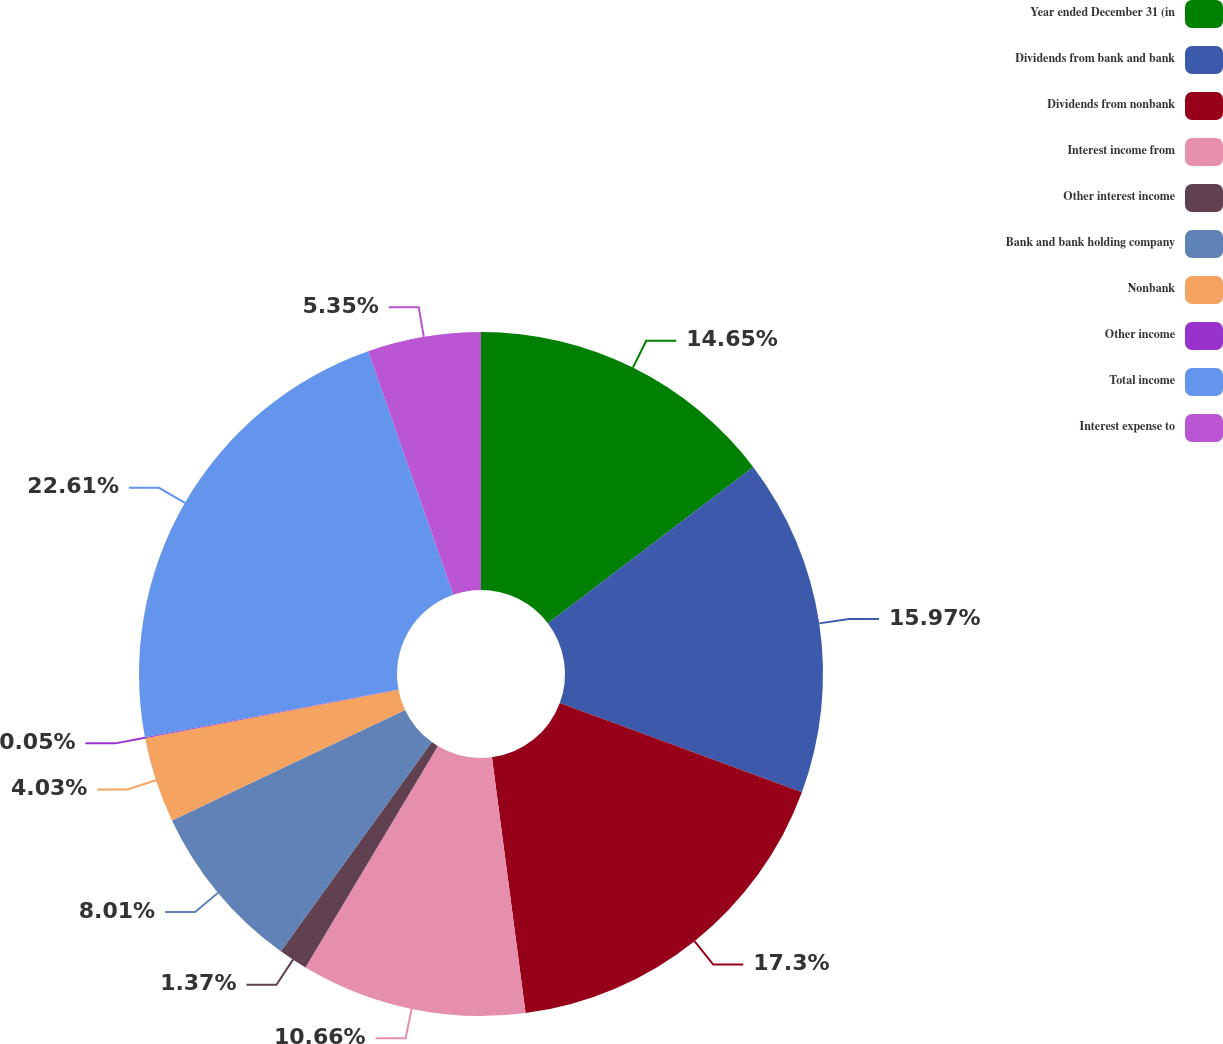<chart> <loc_0><loc_0><loc_500><loc_500><pie_chart><fcel>Year ended December 31 (in<fcel>Dividends from bank and bank<fcel>Dividends from nonbank<fcel>Interest income from<fcel>Other interest income<fcel>Bank and bank holding company<fcel>Nonbank<fcel>Other income<fcel>Total income<fcel>Interest expense to<nl><fcel>14.65%<fcel>15.97%<fcel>17.3%<fcel>10.66%<fcel>1.37%<fcel>8.01%<fcel>4.03%<fcel>0.05%<fcel>22.61%<fcel>5.35%<nl></chart> 